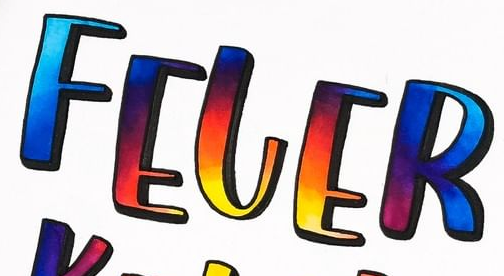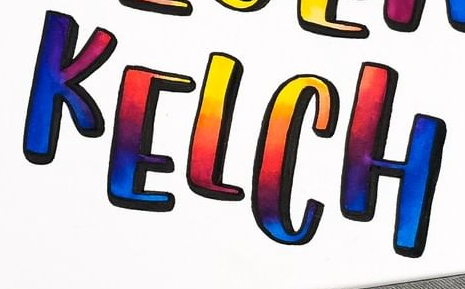What words can you see in these images in sequence, separated by a semicolon? FELER; KELCH 